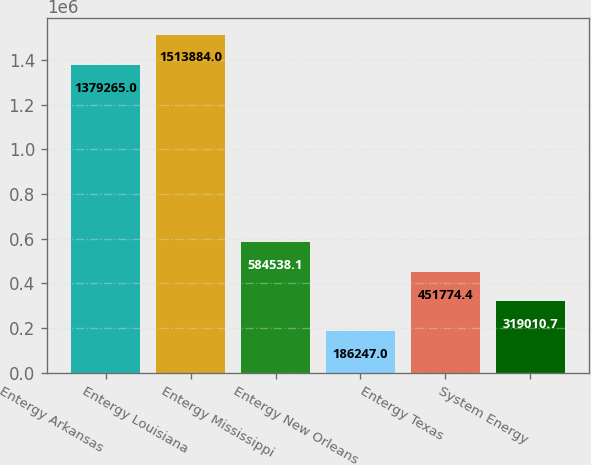Convert chart. <chart><loc_0><loc_0><loc_500><loc_500><bar_chart><fcel>Entergy Arkansas<fcel>Entergy Louisiana<fcel>Entergy Mississippi<fcel>Entergy New Orleans<fcel>Entergy Texas<fcel>System Energy<nl><fcel>1.37926e+06<fcel>1.51388e+06<fcel>584538<fcel>186247<fcel>451774<fcel>319011<nl></chart> 